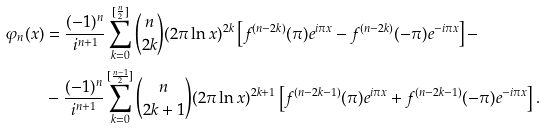Convert formula to latex. <formula><loc_0><loc_0><loc_500><loc_500>\varphi _ { n } ( x ) & = \frac { ( - 1 ) ^ { n } } { i ^ { n + 1 } } \sum _ { k = 0 } ^ { [ \frac { n } { 2 } ] } \binom { n } { 2 k } ( 2 \pi \ln { x } ) ^ { 2 k } \left [ f ^ { ( n - 2 k ) } ( \pi ) e ^ { i \pi x } - f ^ { ( n - 2 k ) } ( - \pi ) e ^ { - i \pi x } \right ] - \\ & - \frac { ( - 1 ) ^ { n } } { i ^ { n + 1 } } \sum _ { k = 0 } ^ { [ \frac { n - 1 } { 2 } ] } \binom { n } { 2 k + 1 } ( 2 \pi \ln { x } ) ^ { 2 k + 1 } \left [ f ^ { ( n - 2 k - 1 ) } ( \pi ) e ^ { i \pi x } + f ^ { ( n - 2 k - 1 ) } ( - \pi ) e ^ { - i \pi x } \right ] .</formula> 